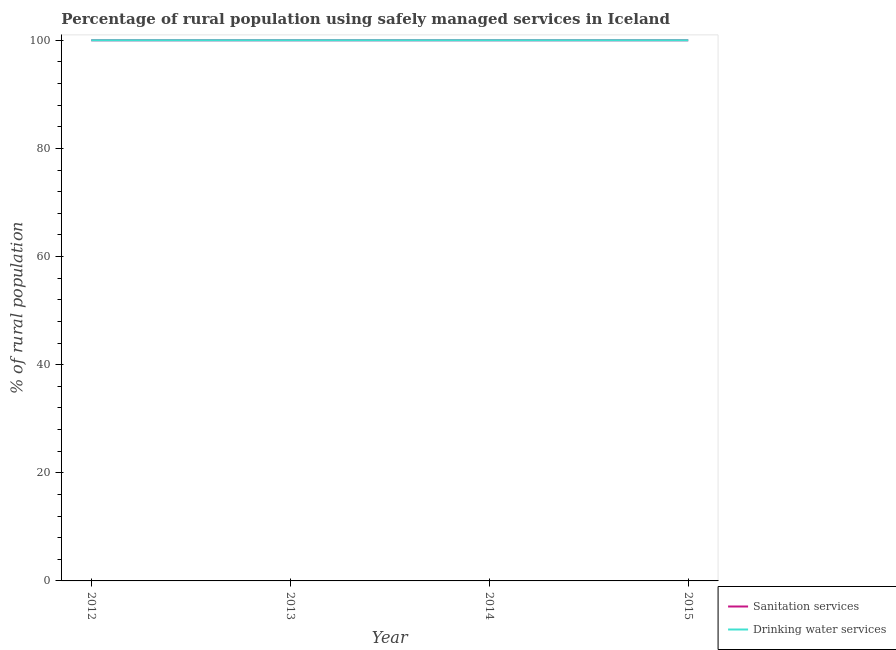Does the line corresponding to percentage of rural population who used drinking water services intersect with the line corresponding to percentage of rural population who used sanitation services?
Offer a terse response. Yes. What is the percentage of rural population who used drinking water services in 2014?
Your response must be concise. 100. Across all years, what is the maximum percentage of rural population who used sanitation services?
Your answer should be compact. 100. Across all years, what is the minimum percentage of rural population who used drinking water services?
Provide a short and direct response. 100. In which year was the percentage of rural population who used drinking water services maximum?
Provide a short and direct response. 2012. In which year was the percentage of rural population who used drinking water services minimum?
Offer a very short reply. 2012. What is the total percentage of rural population who used sanitation services in the graph?
Provide a short and direct response. 400. What is the average percentage of rural population who used drinking water services per year?
Provide a short and direct response. 100. In how many years, is the percentage of rural population who used drinking water services greater than 28 %?
Offer a terse response. 4. Is the percentage of rural population who used drinking water services in 2012 less than that in 2015?
Give a very brief answer. No. In how many years, is the percentage of rural population who used sanitation services greater than the average percentage of rural population who used sanitation services taken over all years?
Offer a very short reply. 0. Is the percentage of rural population who used sanitation services strictly greater than the percentage of rural population who used drinking water services over the years?
Provide a succinct answer. No. How many lines are there?
Keep it short and to the point. 2. Does the graph contain any zero values?
Make the answer very short. No. Where does the legend appear in the graph?
Provide a succinct answer. Bottom right. What is the title of the graph?
Offer a terse response. Percentage of rural population using safely managed services in Iceland. Does "Mobile cellular" appear as one of the legend labels in the graph?
Provide a short and direct response. No. What is the label or title of the X-axis?
Your answer should be compact. Year. What is the label or title of the Y-axis?
Keep it short and to the point. % of rural population. What is the % of rural population in Sanitation services in 2013?
Your answer should be very brief. 100. What is the % of rural population of Drinking water services in 2013?
Ensure brevity in your answer.  100. What is the % of rural population in Drinking water services in 2014?
Offer a very short reply. 100. What is the % of rural population of Sanitation services in 2015?
Keep it short and to the point. 100. Across all years, what is the maximum % of rural population of Sanitation services?
Your answer should be very brief. 100. Across all years, what is the minimum % of rural population in Sanitation services?
Provide a short and direct response. 100. What is the total % of rural population of Sanitation services in the graph?
Your answer should be compact. 400. What is the total % of rural population of Drinking water services in the graph?
Make the answer very short. 400. What is the difference between the % of rural population of Sanitation services in 2012 and that in 2015?
Provide a succinct answer. 0. What is the difference between the % of rural population of Sanitation services in 2013 and that in 2015?
Your answer should be compact. 0. What is the difference between the % of rural population of Sanitation services in 2014 and that in 2015?
Your answer should be compact. 0. What is the difference between the % of rural population in Sanitation services in 2012 and the % of rural population in Drinking water services in 2015?
Ensure brevity in your answer.  0. What is the difference between the % of rural population of Sanitation services in 2013 and the % of rural population of Drinking water services in 2015?
Your answer should be very brief. 0. What is the average % of rural population in Sanitation services per year?
Your answer should be very brief. 100. What is the average % of rural population of Drinking water services per year?
Ensure brevity in your answer.  100. In the year 2013, what is the difference between the % of rural population of Sanitation services and % of rural population of Drinking water services?
Make the answer very short. 0. In the year 2014, what is the difference between the % of rural population in Sanitation services and % of rural population in Drinking water services?
Offer a terse response. 0. In the year 2015, what is the difference between the % of rural population in Sanitation services and % of rural population in Drinking water services?
Ensure brevity in your answer.  0. What is the ratio of the % of rural population in Sanitation services in 2012 to that in 2013?
Offer a very short reply. 1. What is the ratio of the % of rural population of Sanitation services in 2012 to that in 2015?
Make the answer very short. 1. What is the ratio of the % of rural population of Drinking water services in 2012 to that in 2015?
Ensure brevity in your answer.  1. What is the ratio of the % of rural population of Drinking water services in 2013 to that in 2014?
Provide a short and direct response. 1. What is the ratio of the % of rural population in Drinking water services in 2013 to that in 2015?
Your response must be concise. 1. What is the ratio of the % of rural population in Sanitation services in 2014 to that in 2015?
Make the answer very short. 1. What is the ratio of the % of rural population in Drinking water services in 2014 to that in 2015?
Offer a terse response. 1. What is the difference between the highest and the second highest % of rural population of Sanitation services?
Provide a succinct answer. 0. What is the difference between the highest and the lowest % of rural population of Sanitation services?
Keep it short and to the point. 0. What is the difference between the highest and the lowest % of rural population in Drinking water services?
Give a very brief answer. 0. 